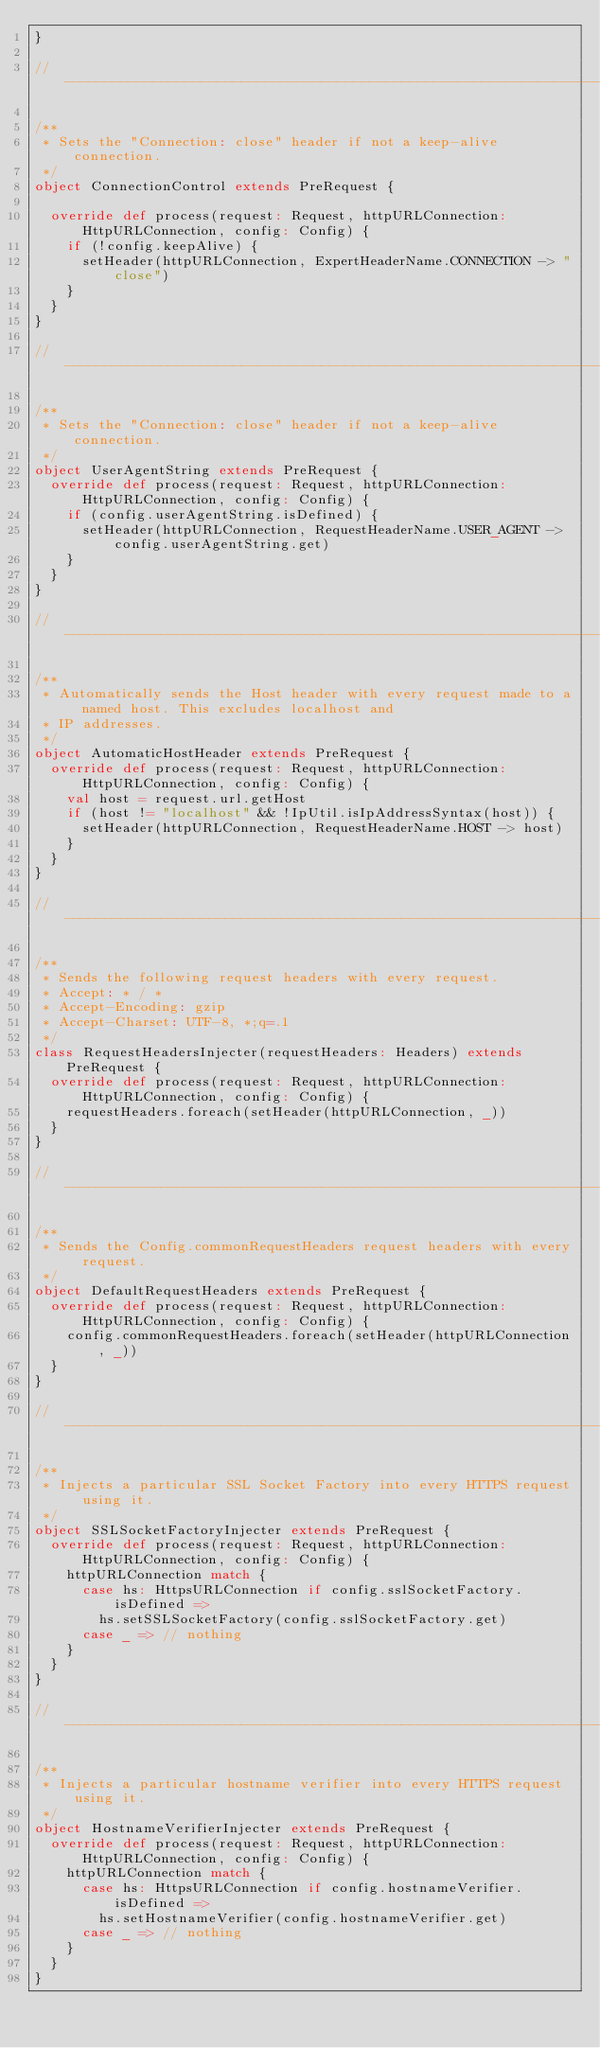<code> <loc_0><loc_0><loc_500><loc_500><_Scala_>}

//---------------------------------------------------------------------------------------------------------------------

/**
 * Sets the "Connection: close" header if not a keep-alive connection.
 */
object ConnectionControl extends PreRequest {

  override def process(request: Request, httpURLConnection: HttpURLConnection, config: Config) {
    if (!config.keepAlive) {
      setHeader(httpURLConnection, ExpertHeaderName.CONNECTION -> "close")
    }
  }
}

//---------------------------------------------------------------------------------------------------------------------

/**
 * Sets the "Connection: close" header if not a keep-alive connection.
 */
object UserAgentString extends PreRequest {
  override def process(request: Request, httpURLConnection: HttpURLConnection, config: Config) {
    if (config.userAgentString.isDefined) {
      setHeader(httpURLConnection, RequestHeaderName.USER_AGENT -> config.userAgentString.get)
    }
  }
}

//---------------------------------------------------------------------------------------------------------------------

/**
 * Automatically sends the Host header with every request made to a named host. This excludes localhost and
 * IP addresses.
 */
object AutomaticHostHeader extends PreRequest {
  override def process(request: Request, httpURLConnection: HttpURLConnection, config: Config) {
    val host = request.url.getHost
    if (host != "localhost" && !IpUtil.isIpAddressSyntax(host)) {
      setHeader(httpURLConnection, RequestHeaderName.HOST -> host)
    }
  }
}

//---------------------------------------------------------------------------------------------------------------------

/**
 * Sends the following request headers with every request.
 * Accept: * / *
 * Accept-Encoding: gzip
 * Accept-Charset: UTF-8, *;q=.1
 */
class RequestHeadersInjecter(requestHeaders: Headers) extends PreRequest {
  override def process(request: Request, httpURLConnection: HttpURLConnection, config: Config) {
    requestHeaders.foreach(setHeader(httpURLConnection, _))
  }
}

//---------------------------------------------------------------------------------------------------------------------

/**
 * Sends the Config.commonRequestHeaders request headers with every request.
 */
object DefaultRequestHeaders extends PreRequest {
  override def process(request: Request, httpURLConnection: HttpURLConnection, config: Config) {
    config.commonRequestHeaders.foreach(setHeader(httpURLConnection, _))
  }
}

//---------------------------------------------------------------------------------------------------------------------

/**
 * Injects a particular SSL Socket Factory into every HTTPS request using it.
 */
object SSLSocketFactoryInjecter extends PreRequest {
  override def process(request: Request, httpURLConnection: HttpURLConnection, config: Config) {
    httpURLConnection match {
      case hs: HttpsURLConnection if config.sslSocketFactory.isDefined =>
        hs.setSSLSocketFactory(config.sslSocketFactory.get)
      case _ => // nothing
    }
  }
}

//---------------------------------------------------------------------------------------------------------------------

/**
 * Injects a particular hostname verifier into every HTTPS request using it.
 */
object HostnameVerifierInjecter extends PreRequest {
  override def process(request: Request, httpURLConnection: HttpURLConnection, config: Config) {
    httpURLConnection match {
      case hs: HttpsURLConnection if config.hostnameVerifier.isDefined =>
        hs.setHostnameVerifier(config.hostnameVerifier.get)
      case _ => // nothing
    }
  }
}


</code> 